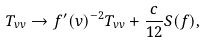Convert formula to latex. <formula><loc_0><loc_0><loc_500><loc_500>T _ { v v } \to f ^ { \prime } ( v ) ^ { - 2 } T _ { v v } + \frac { c } { 1 2 } S ( f ) ,</formula> 